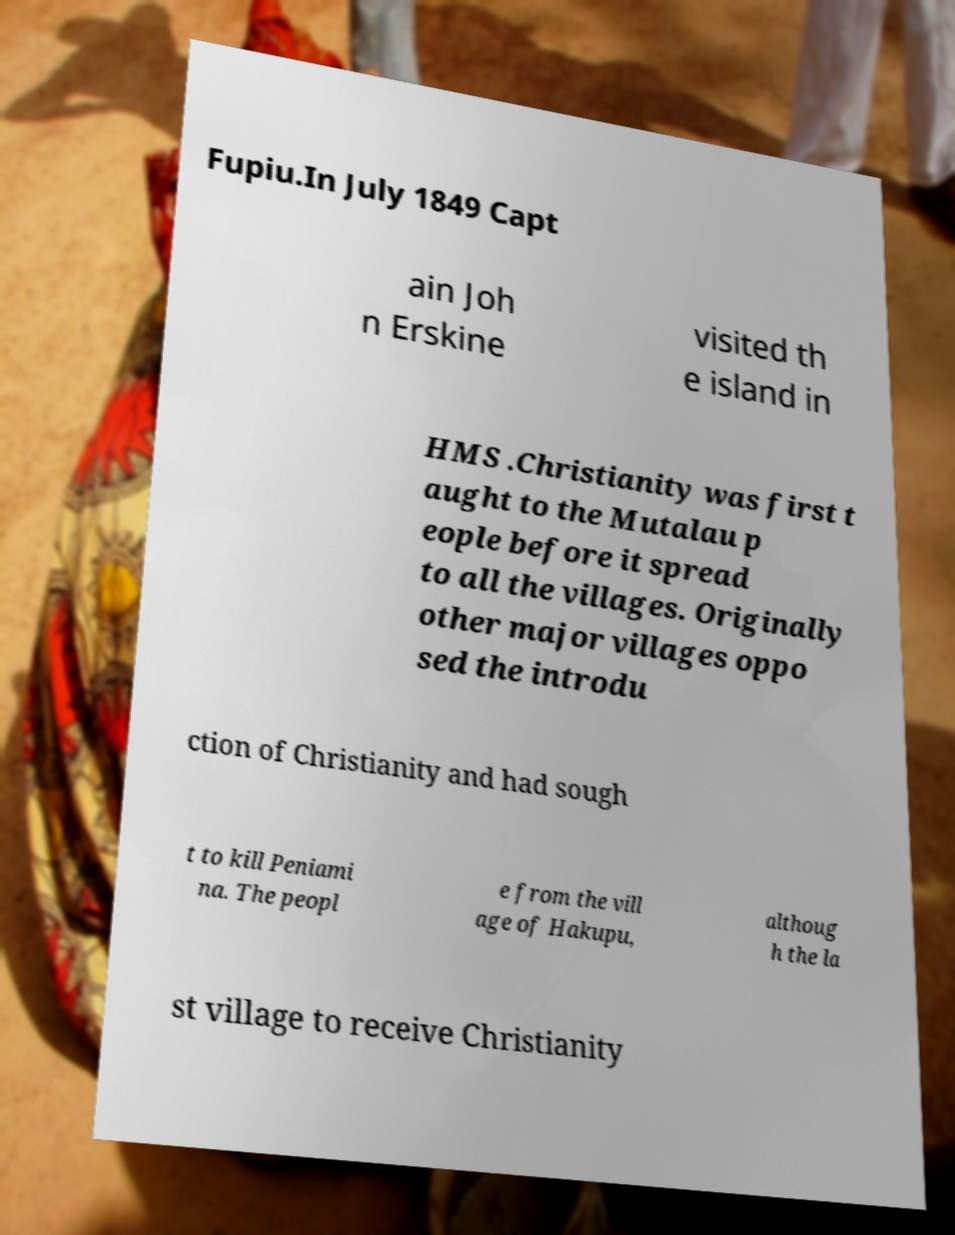What messages or text are displayed in this image? I need them in a readable, typed format. Fupiu.In July 1849 Capt ain Joh n Erskine visited th e island in HMS .Christianity was first t aught to the Mutalau p eople before it spread to all the villages. Originally other major villages oppo sed the introdu ction of Christianity and had sough t to kill Peniami na. The peopl e from the vill age of Hakupu, althoug h the la st village to receive Christianity 